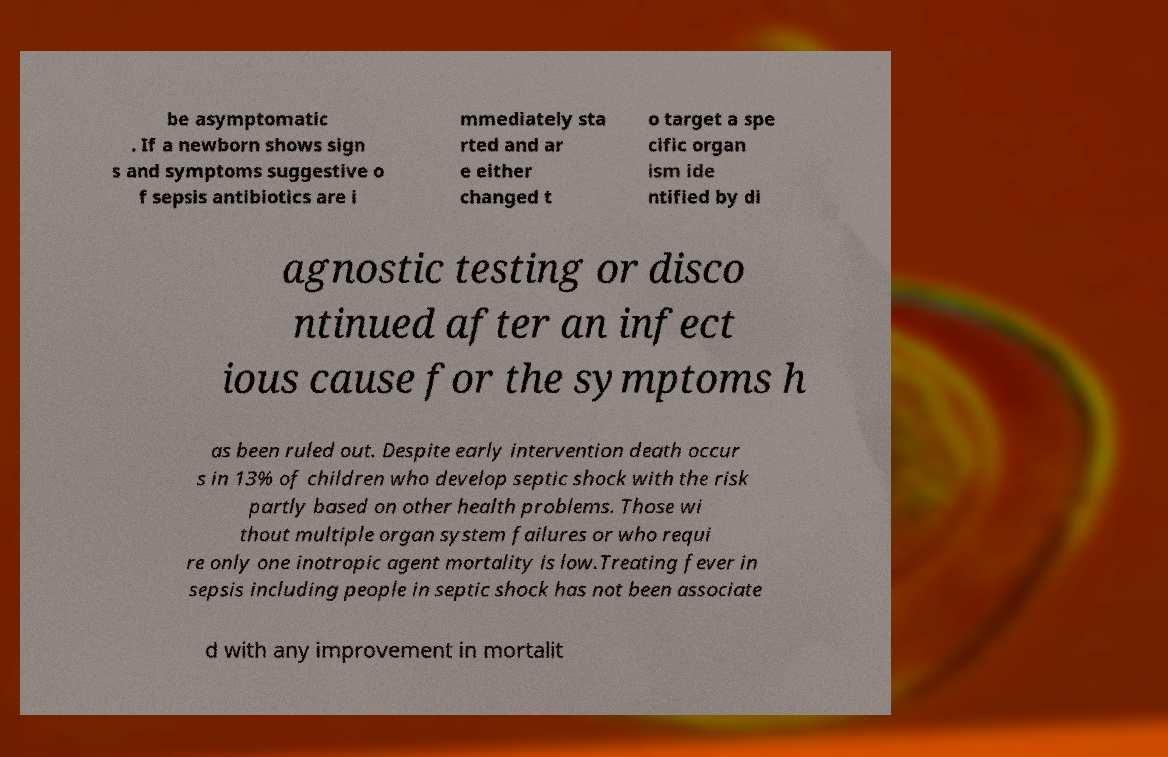Could you assist in decoding the text presented in this image and type it out clearly? be asymptomatic . If a newborn shows sign s and symptoms suggestive o f sepsis antibiotics are i mmediately sta rted and ar e either changed t o target a spe cific organ ism ide ntified by di agnostic testing or disco ntinued after an infect ious cause for the symptoms h as been ruled out. Despite early intervention death occur s in 13% of children who develop septic shock with the risk partly based on other health problems. Those wi thout multiple organ system failures or who requi re only one inotropic agent mortality is low.Treating fever in sepsis including people in septic shock has not been associate d with any improvement in mortalit 